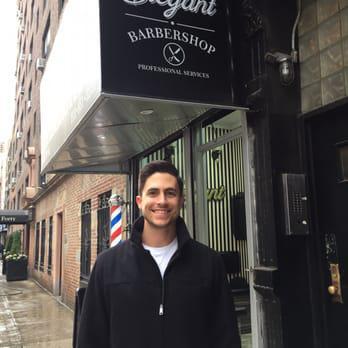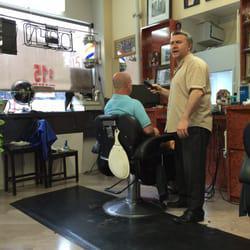The first image is the image on the left, the second image is the image on the right. For the images displayed, is the sentence "There are more people in the barber shop in the right image." factually correct? Answer yes or no. Yes. The first image is the image on the left, the second image is the image on the right. Examine the images to the left and right. Is the description "The right image has only one person giving a haircut, and one person cutting hair." accurate? Answer yes or no. Yes. 